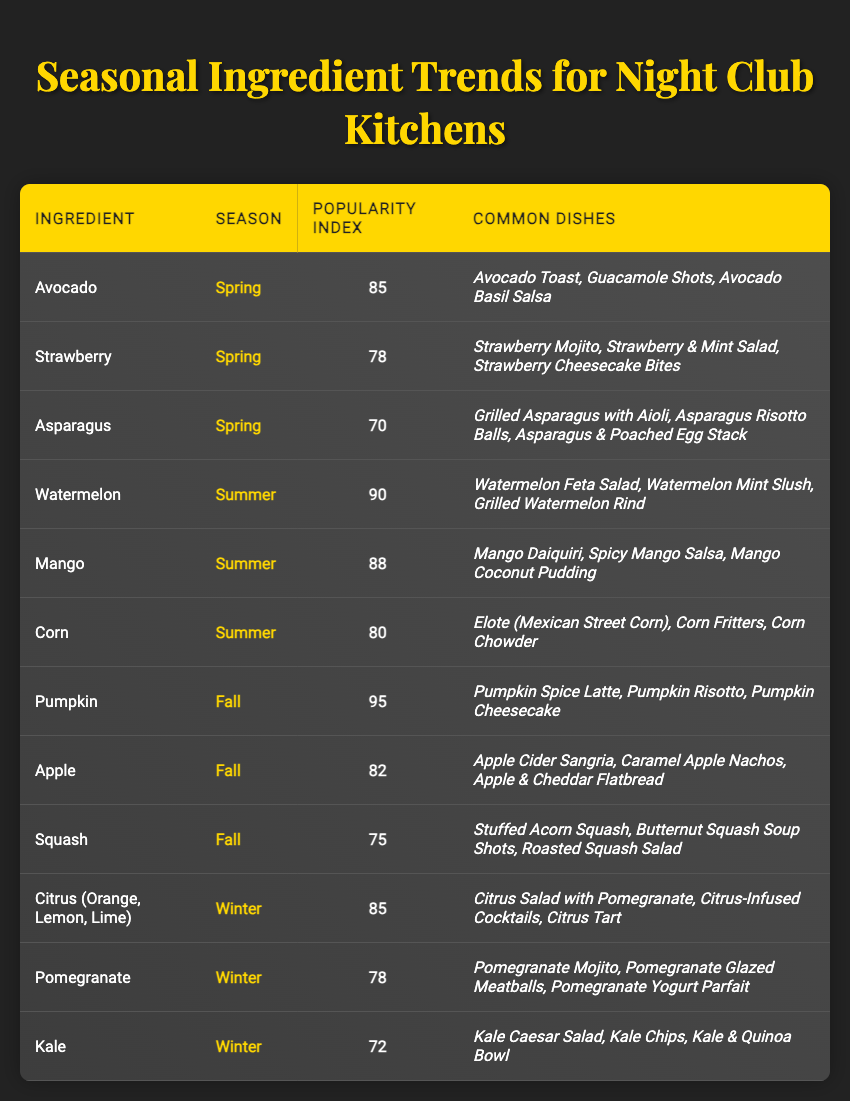What ingredient has the highest popularity index in Fall? The table lists three ingredients for Fall: Pumpkin (95), Apple (82), and Squash (75). Since 95 is the highest among these, Pumpkin has the highest popularity index in Fall.
Answer: Pumpkin Which ingredient is common in Spring and has a popularity index above 75? In Spring, Avocado (85), Strawberry (78), and Asparagus (70) are the ingredients. Both Avocado and Strawberry have popularity indices above 75 (85 and 78, respectively), so the answer includes both Avocado and Strawberry.
Answer: Avocado, Strawberry What is the popularity index of Kale? Kale is listed under Winter with a popularity index of 72 as per the table.
Answer: 72 Which season has the highest popularity index value for its ingredient? The highest popularity index is 95 for Pumpkin in Fall. By comparing all seasons, Fall has the highest value, followed by Summer (90 for Watermelon), Spring (85 for Avocado), and Winter (85 for Citrus).
Answer: Fall Are there any ingredients in Winter with a popularity index greater than 80? The ingredients for Winter are Citrus (85), Pomegranate (78), and Kale (72). Only Citrus has a popularity index greater than 80 (85). So, the answer is yes.
Answer: Yes What is the average popularity index for ingredients in Summer? The popularity indices for Summer ingredients are Watermelon (90), Mango (88), and Corn (80). To find the average, we sum these indices (90 + 88 + 80 = 258) and divide by the number of ingredients (3). The average is 258/3 = 86.
Answer: 86 Which ingredient appears with a popularity index less than 75 in Fall? The ingredients listed for Fall are Pumpkin (95), Apple (82), and Squash (75). Squash is explicitly noted as having a popularity index of 75. No ingredient in Fall has a popularity index less than 75.
Answer: No What is the trend in popularity indices from Spring to Winter for ingredients? The popularity indices for ingredients across the seasons are Spring: Avocado (85), Strawberry (78), Asparagus (70); Summer: Watermelon (90), Mango (88), Corn (80); Fall: Pumpkin (95), Apple (82), Squash (75); Winter: Citrus (85), Pomegranate (78), Kale (72). Observing the trend, it rises in Spring, peaks in Fall (95), and then dips in Winter.
Answer: Rises and peaks in Fall, then dips in Winter Which ingredient common in Summer has a higher popularity index than any Winter ingredient? Comparing Summer ingredients—Watermelon (90), Mango (88), Corn (80)—to Winter ingredients—Citrus (85), Pomegranate (78), Kale (72)—both Watermelon (90) and Mango (88) have indices higher than any Winter ingredient.
Answer: Watermelon, Mango What dish is commonly associated with Pumpkin in Fall? The common dishes listed with Pumpkin include Pumpkin Spice Latte, Pumpkin Risotto, and Pumpkin Cheesecake.
Answer: Pumpkin Spice Latte, Pumpkin Risotto, Pumpkin Cheesecake Does Summer have more ingredients with a popularity index above 80 than Fall? Summer has three ingredients: Watermelon (90), Mango (88), and Corn (80), where all three are above 80. Fall has three ingredients—Pumpkin (95), Apple (82), and Squash (75)—where only Pumpkin and Apple are above 80. Thus, Summer has more (3) than Fall (2).
Answer: Yes 